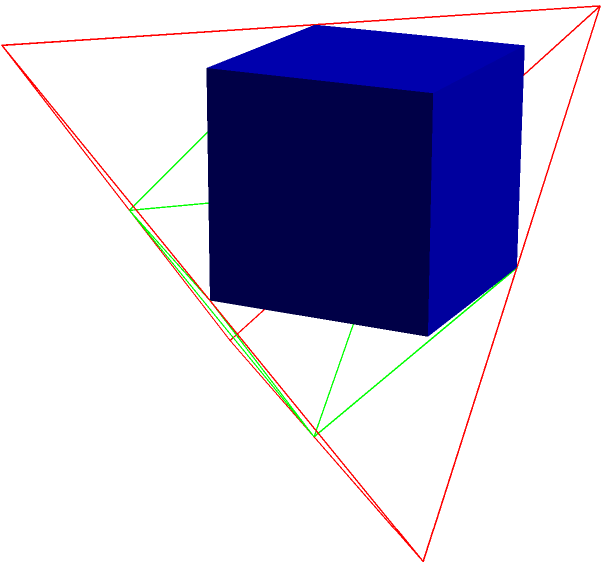In the image, three Platonic solids are depicted: a blue cube, a red tetrahedron, and a green octahedron. Calculate the Euler characteristic for each of these polyhedra and explain its significance in terms of topology. How does this relate to the concept of genus in surface topology? Let's approach this step-by-step:

1. The Euler characteristic ($\chi$) is defined as $\chi = V - E + F$, where V is the number of vertices, E is the number of edges, and F is the number of faces.

2. For the cube:
   V = 8, E = 12, F = 6
   $\chi_{cube} = 8 - 12 + 6 = 2$

3. For the tetrahedron:
   V = 4, E = 6, F = 4
   $\chi_{tetrahedron} = 4 - 6 + 4 = 2$

4. For the octahedron:
   V = 6, E = 12, F = 8
   $\chi_{octahedron} = 6 - 12 + 8 = 2$

5. We observe that all three polyhedra have the same Euler characteristic of 2. This is not a coincidence; it's a fundamental property of all convex polyhedra.

6. The significance of the Euler characteristic in topology:
   - It's a topological invariant, meaning it doesn't change under continuous deformations of the surface.
   - For closed surfaces, $\chi = 2 - 2g$, where g is the genus (number of "holes" in the surface).

7. Relating to genus:
   - All these polyhedra have $\chi = 2$, which implies $g = 0$.
   - This means they are all topologically equivalent to a sphere, which has no holes.

8. The Euler characteristic demonstrates that despite their different appearances, these polyhedra are topologically identical. They can be continuously deformed into one another without cutting or gluing.

9. This concept extends to more complex surfaces. For example:
   - A torus has $\chi = 0$ and $g = 1$
   - A double torus has $\chi = -2$ and $g = 2$

Understanding the Euler characteristic and its relation to genus provides a powerful tool for classifying and understanding the fundamental properties of surfaces in topology.
Answer: $\chi = 2$ for all; topologically equivalent to sphere (genus 0) 